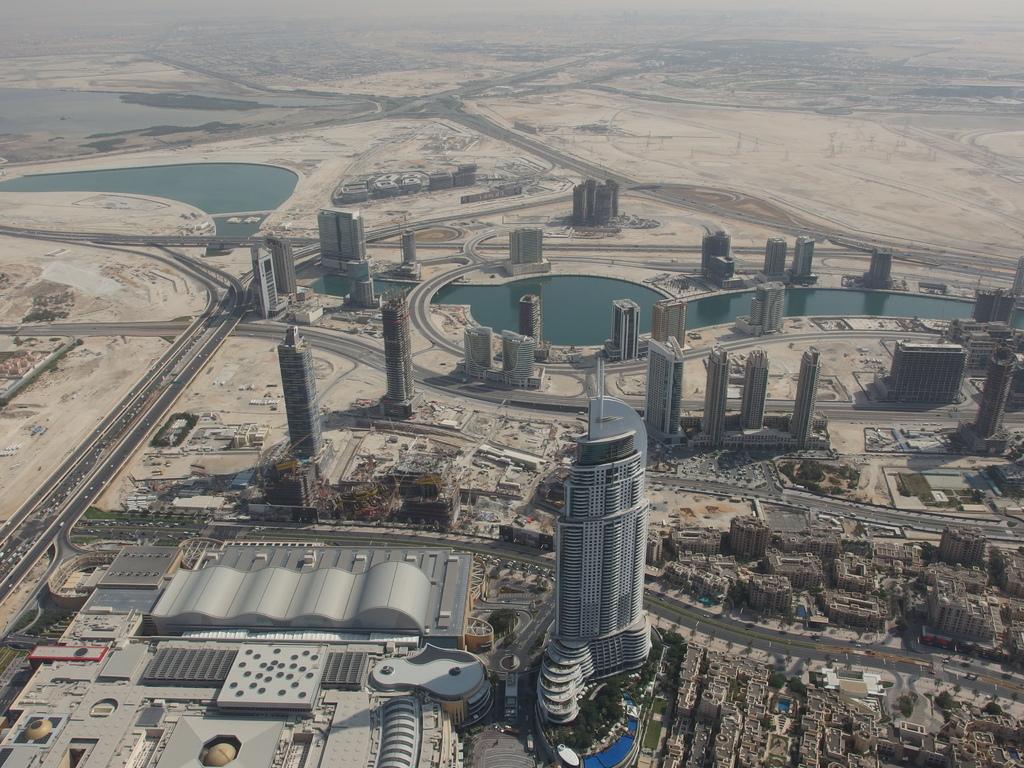Describe this image in one or two sentences. This is an aerial view of a city. There are buildings, roads, water and desert. 